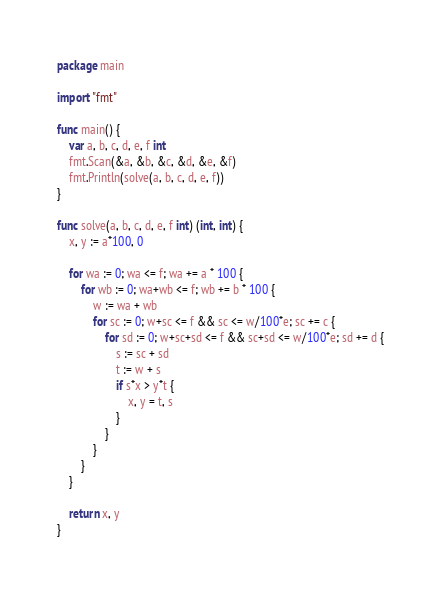Convert code to text. <code><loc_0><loc_0><loc_500><loc_500><_Go_>package main

import "fmt"

func main() {
	var a, b, c, d, e, f int
	fmt.Scan(&a, &b, &c, &d, &e, &f)
	fmt.Println(solve(a, b, c, d, e, f))
}

func solve(a, b, c, d, e, f int) (int, int) {
	x, y := a*100, 0

	for wa := 0; wa <= f; wa += a * 100 {
		for wb := 0; wa+wb <= f; wb += b * 100 {
			w := wa + wb
			for sc := 0; w+sc <= f && sc <= w/100*e; sc += c {
				for sd := 0; w+sc+sd <= f && sc+sd <= w/100*e; sd += d {
					s := sc + sd
					t := w + s
					if s*x > y*t {
						x, y = t, s
					}
				}
			}
		}
	}

	return x, y
}
</code> 